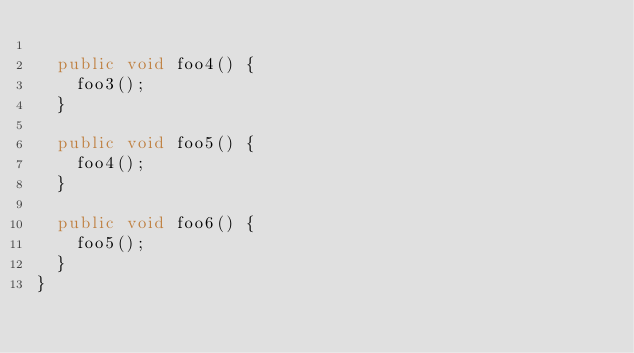Convert code to text. <code><loc_0><loc_0><loc_500><loc_500><_Java_>
  public void foo4() {
    foo3();
  }

  public void foo5() {
    foo4();
  }

  public void foo6() {
    foo5();
  }
}
</code> 